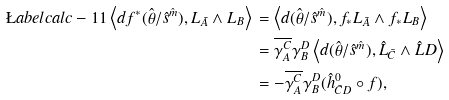<formula> <loc_0><loc_0><loc_500><loc_500>\L a b e l { c a l c - 1 1 } \left < d f ^ { * } ( \hat { \theta } / \hat { s } ^ { \hat { m } } ) , L _ { \bar { A } } \wedge L _ { B } \right > \, & = \left < d ( \hat { \theta } / \hat { s } ^ { \hat { m } } ) , f _ { * } L _ { \bar { A } } \wedge f _ { * } L _ { B } \right > \\ \, & = \overline { \gamma ^ { C } _ { A } } \gamma ^ { D } _ { B } \left < d ( \hat { \theta } / \hat { s } ^ { \hat { m } } ) , \hat { L } _ { \bar { C } } \wedge \hat { L } D \right > \\ \, & = - \overline { \gamma ^ { C } _ { A } } \gamma ^ { D } _ { B } ( \hat { h } ^ { 0 } _ { \bar { C } D } \circ f ) ,</formula> 